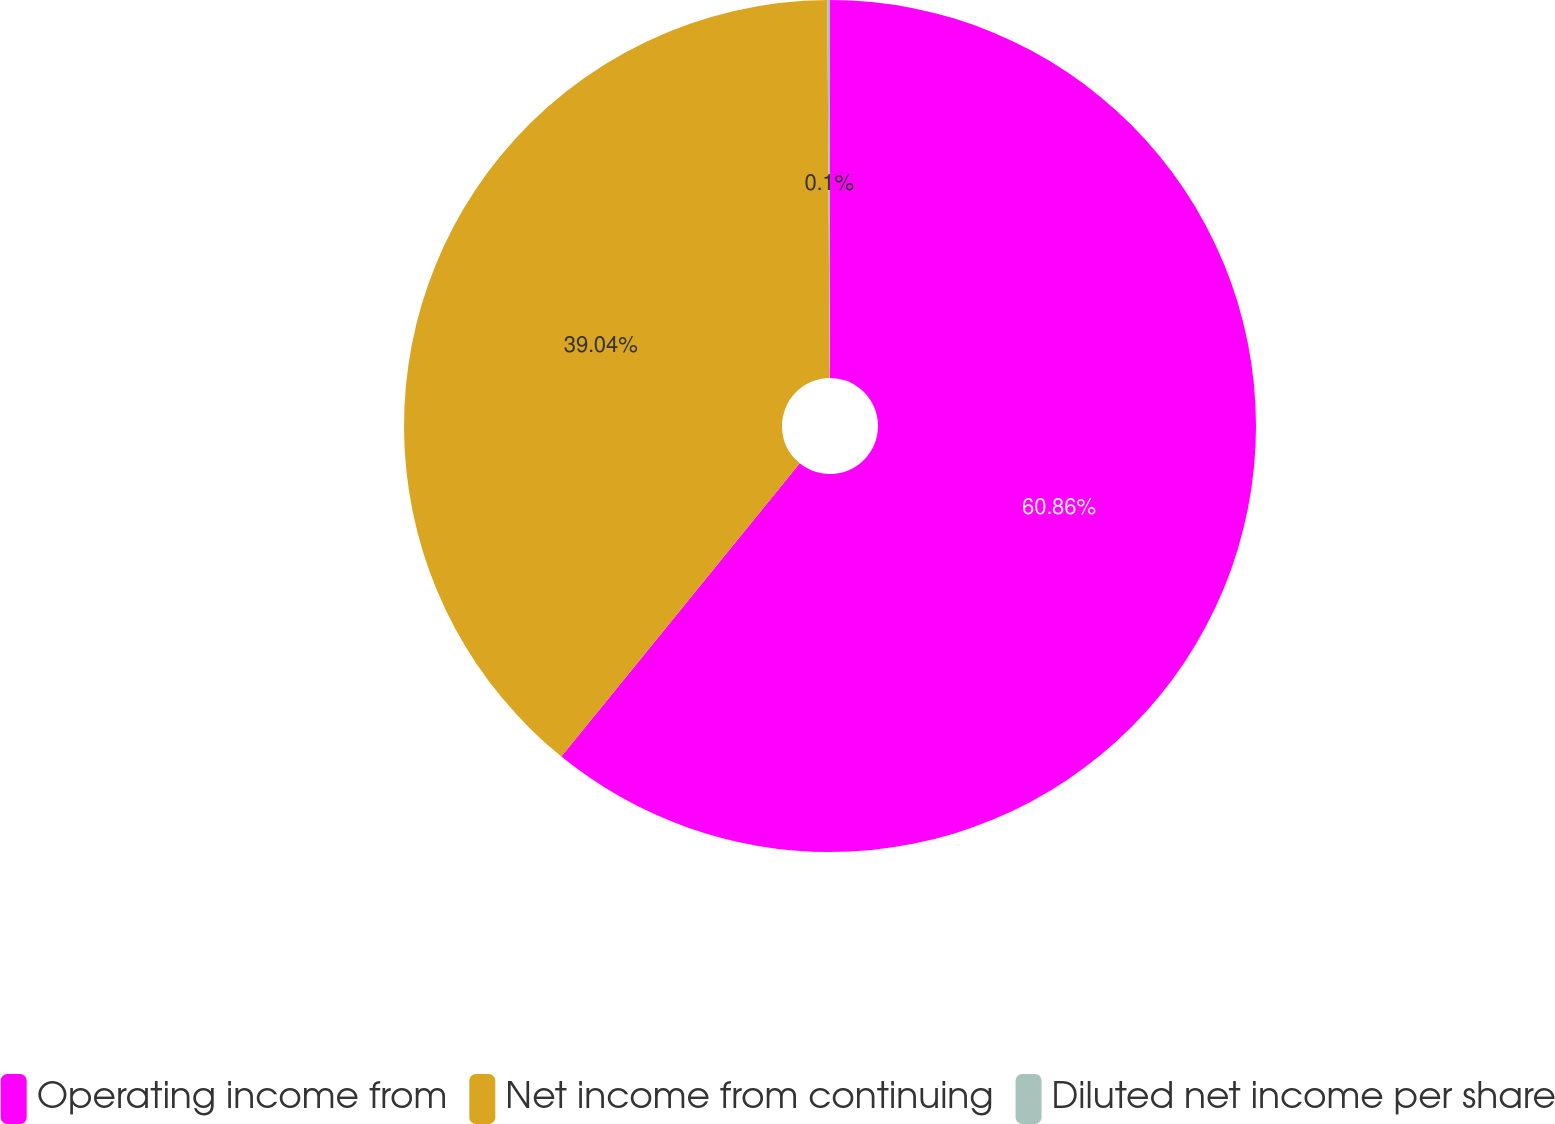<chart> <loc_0><loc_0><loc_500><loc_500><pie_chart><fcel>Operating income from<fcel>Net income from continuing<fcel>Diluted net income per share<nl><fcel>60.86%<fcel>39.04%<fcel>0.1%<nl></chart> 